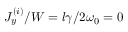<formula> <loc_0><loc_0><loc_500><loc_500>J _ { y } ^ { ( i ) } / W = l \gamma / 2 \omega _ { 0 } = 0</formula> 